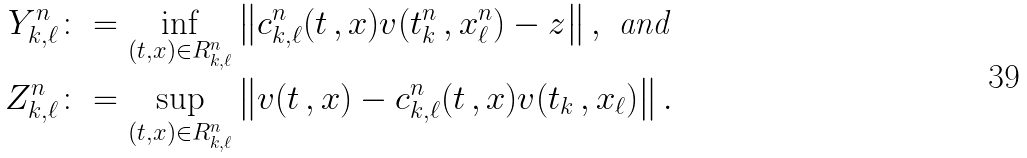<formula> <loc_0><loc_0><loc_500><loc_500>Y _ { k , \ell } ^ { n } & \colon = \inf _ { ( t , x ) \in R _ { k , \ell } ^ { n } } \left \| c _ { k , \ell } ^ { n } ( t \, , x ) v ( t _ { k } ^ { n } \, , x ^ { n } _ { \ell } ) - z \right \| , \ \text {and} \\ Z _ { k , \ell } ^ { n } & \colon = \sup _ { ( t , x ) \in R ^ { n } _ { k , \ell } } \left \| v ( t \, , x ) - c ^ { n } _ { k , \ell } ( t \, , x ) v ( t _ { k } \, , x _ { \ell } ) \right \| .</formula> 